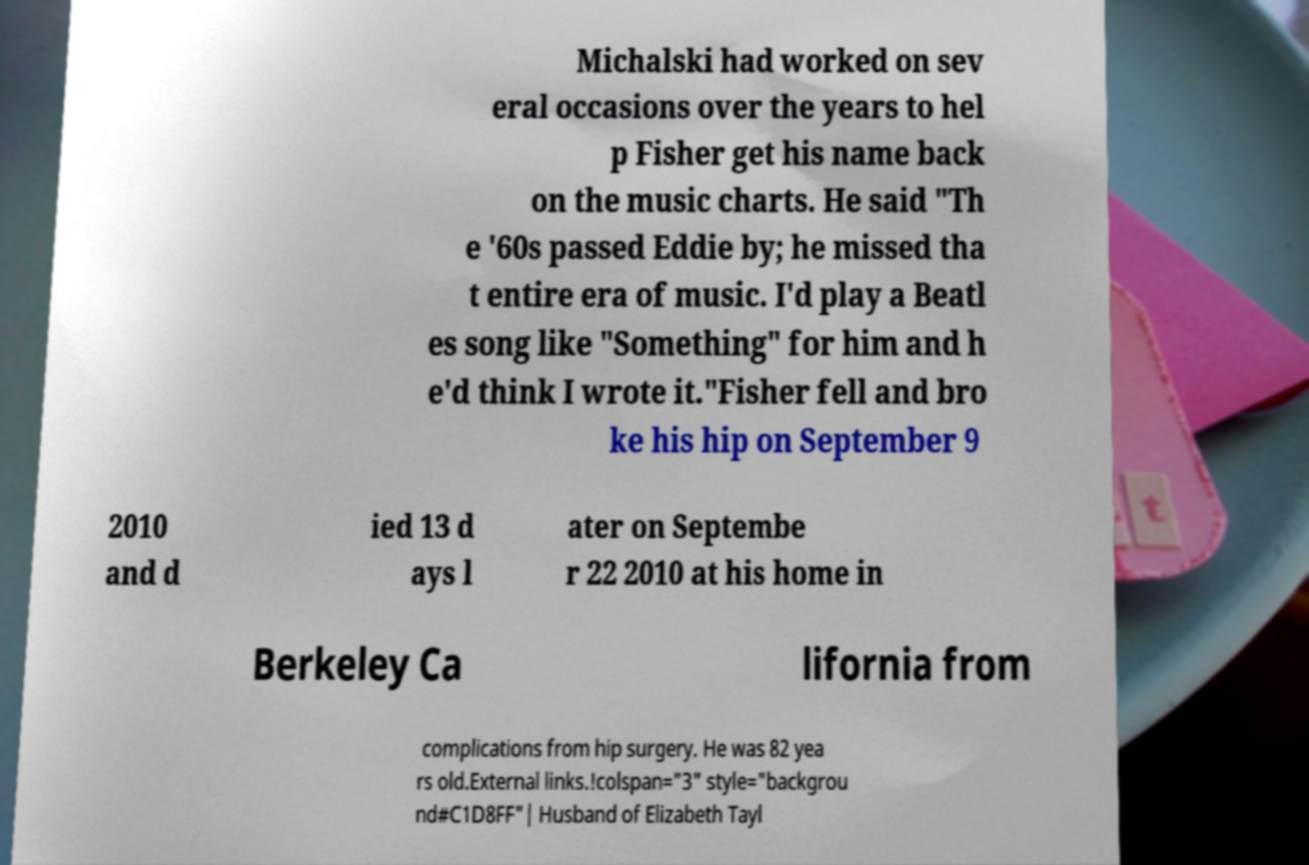Can you accurately transcribe the text from the provided image for me? Michalski had worked on sev eral occasions over the years to hel p Fisher get his name back on the music charts. He said "Th e '60s passed Eddie by; he missed tha t entire era of music. I'd play a Beatl es song like "Something" for him and h e'd think I wrote it."Fisher fell and bro ke his hip on September 9 2010 and d ied 13 d ays l ater on Septembe r 22 2010 at his home in Berkeley Ca lifornia from complications from hip surgery. He was 82 yea rs old.External links.!colspan="3" style="backgrou nd#C1D8FF"| Husband of Elizabeth Tayl 